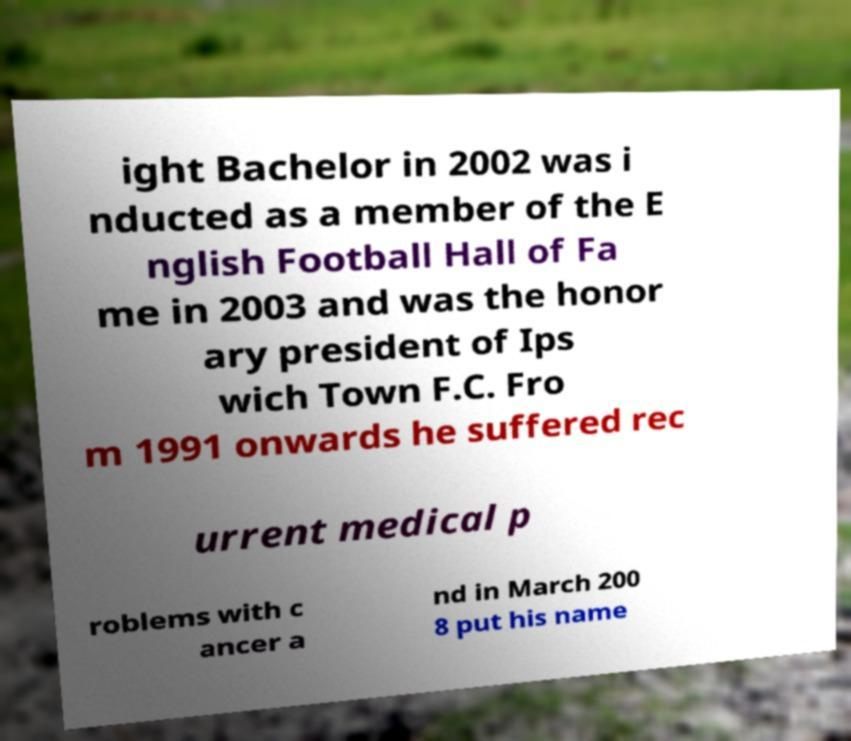Can you read and provide the text displayed in the image?This photo seems to have some interesting text. Can you extract and type it out for me? ight Bachelor in 2002 was i nducted as a member of the E nglish Football Hall of Fa me in 2003 and was the honor ary president of Ips wich Town F.C. Fro m 1991 onwards he suffered rec urrent medical p roblems with c ancer a nd in March 200 8 put his name 